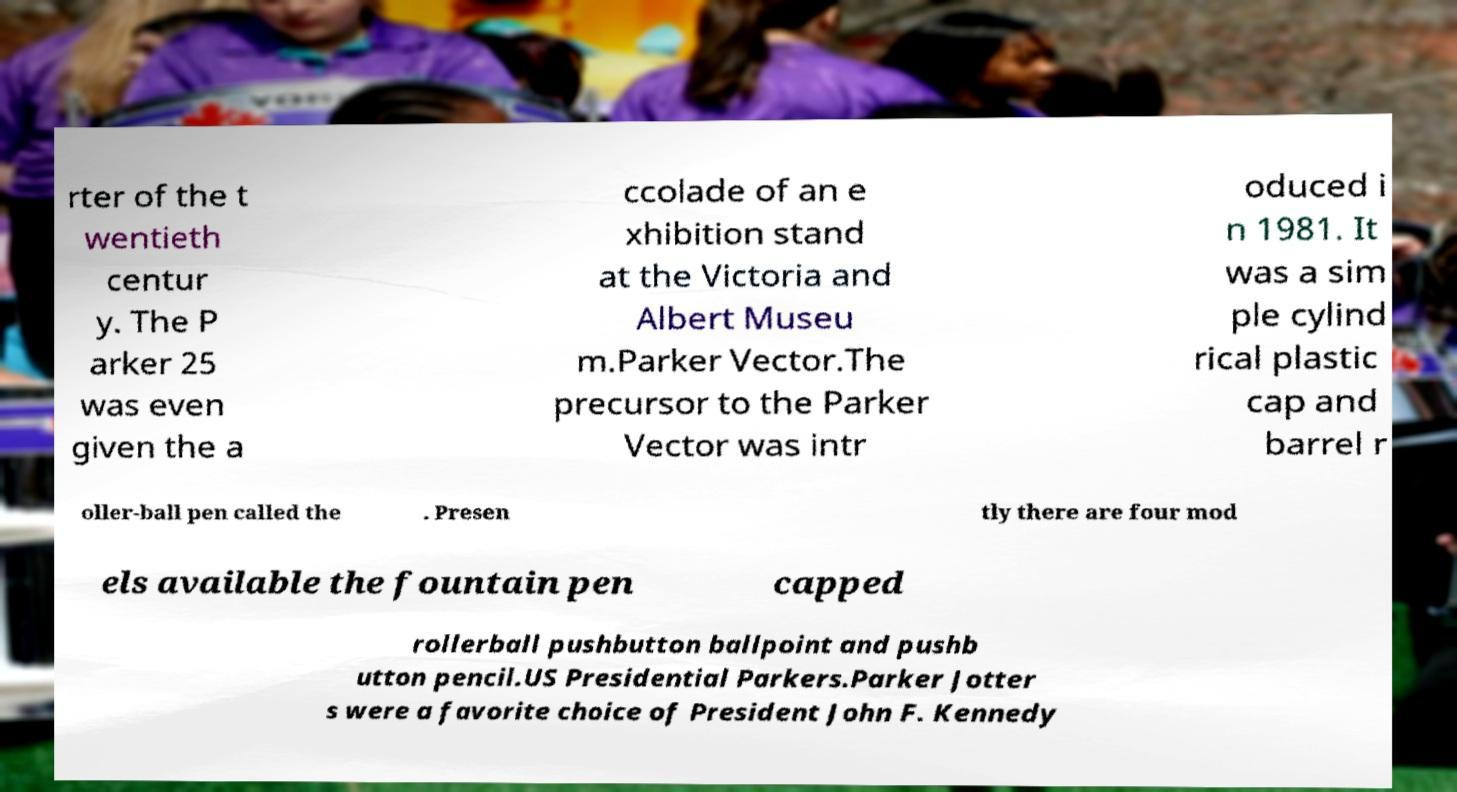For documentation purposes, I need the text within this image transcribed. Could you provide that? rter of the t wentieth centur y. The P arker 25 was even given the a ccolade of an e xhibition stand at the Victoria and Albert Museu m.Parker Vector.The precursor to the Parker Vector was intr oduced i n 1981. It was a sim ple cylind rical plastic cap and barrel r oller-ball pen called the . Presen tly there are four mod els available the fountain pen capped rollerball pushbutton ballpoint and pushb utton pencil.US Presidential Parkers.Parker Jotter s were a favorite choice of President John F. Kennedy 